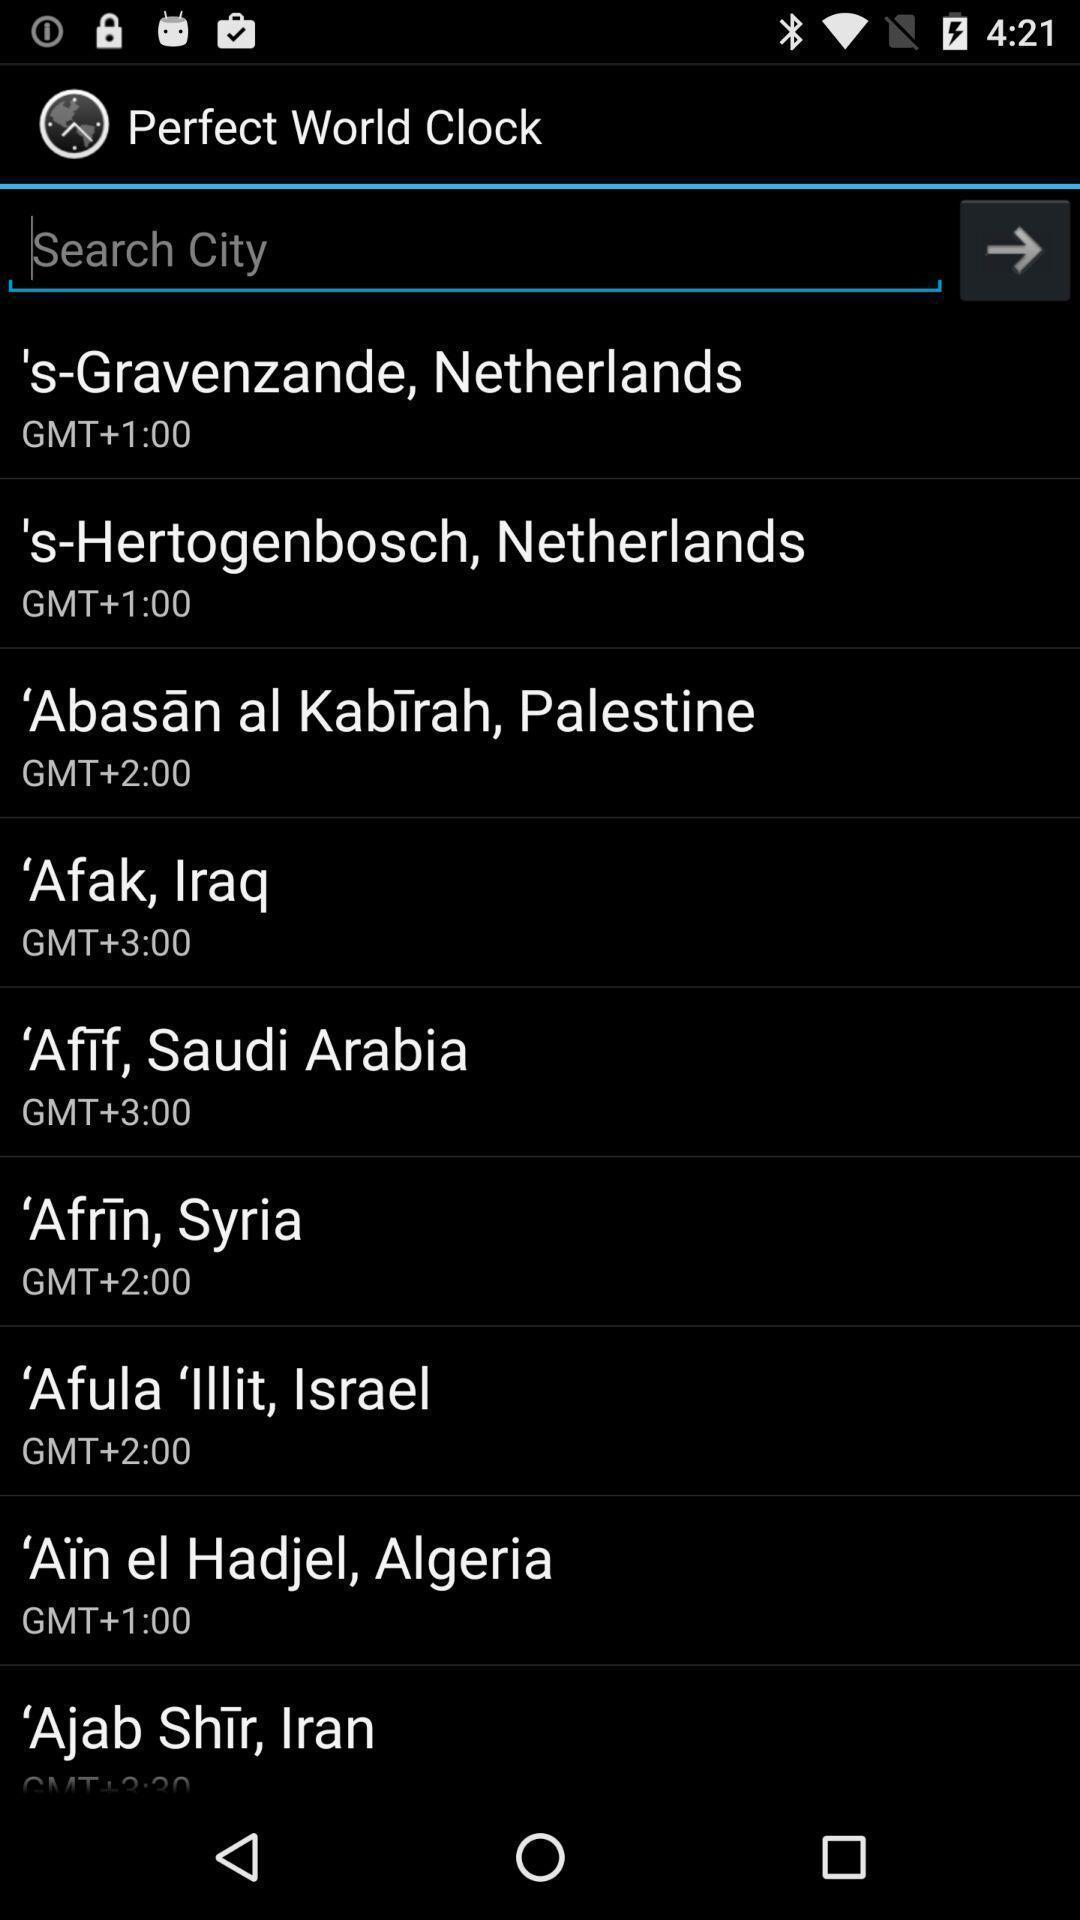Describe the visual elements of this screenshot. Page displaying various cities to select. 